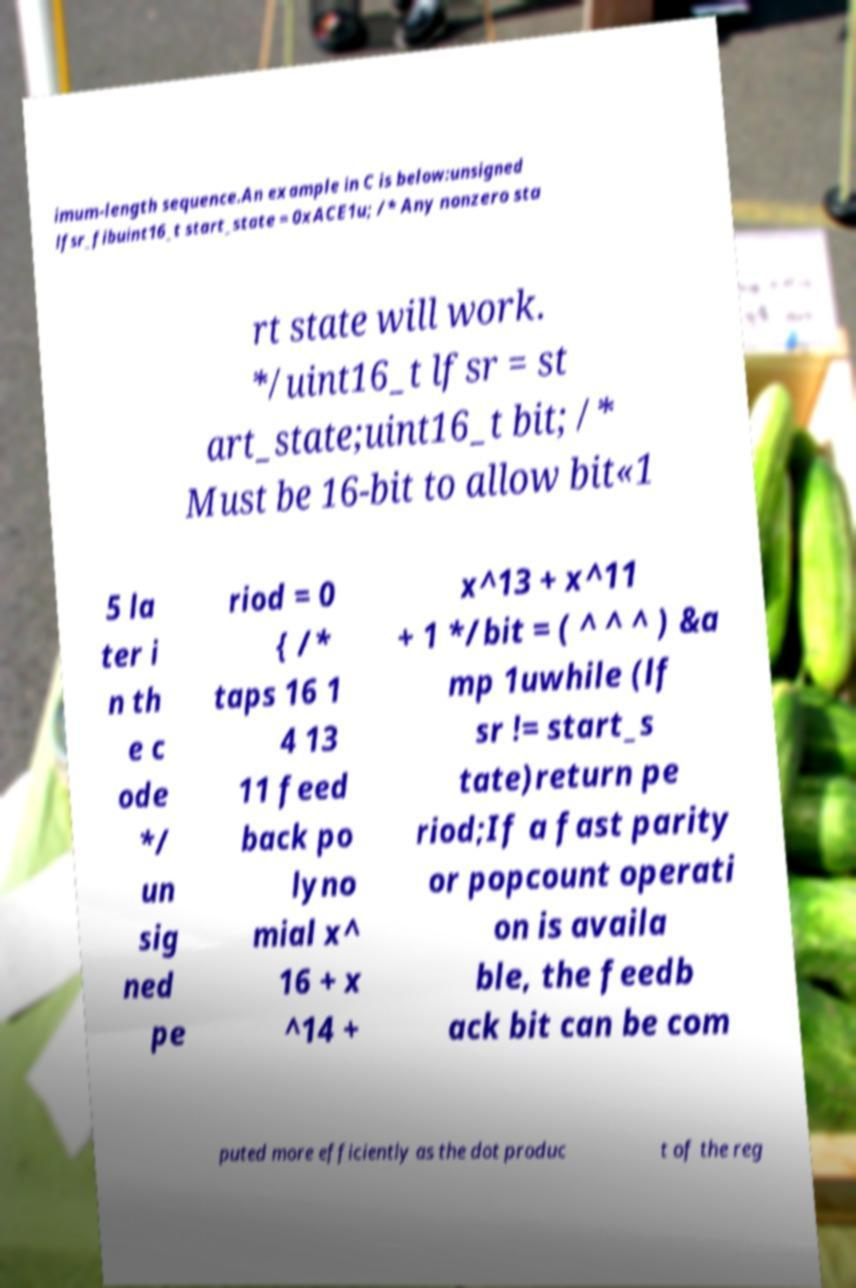Please read and relay the text visible in this image. What does it say? imum-length sequence.An example in C is below:unsigned lfsr_fibuint16_t start_state = 0xACE1u; /* Any nonzero sta rt state will work. */uint16_t lfsr = st art_state;uint16_t bit; /* Must be 16-bit to allow bit«1 5 la ter i n th e c ode */ un sig ned pe riod = 0 { /* taps 16 1 4 13 11 feed back po lyno mial x^ 16 + x ^14 + x^13 + x^11 + 1 */bit = ( ^ ^ ^ ) &a mp 1uwhile (lf sr != start_s tate)return pe riod;If a fast parity or popcount operati on is availa ble, the feedb ack bit can be com puted more efficiently as the dot produc t of the reg 